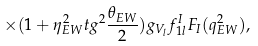Convert formula to latex. <formula><loc_0><loc_0><loc_500><loc_500>\times ( 1 + \eta _ { E W } ^ { 2 } t g ^ { 2 } \frac { \theta _ { E W } } { 2 } ) g _ { V _ { l } } f _ { 1 l } ^ { I } F _ { I } ( q _ { E W } ^ { 2 } ) ,</formula> 